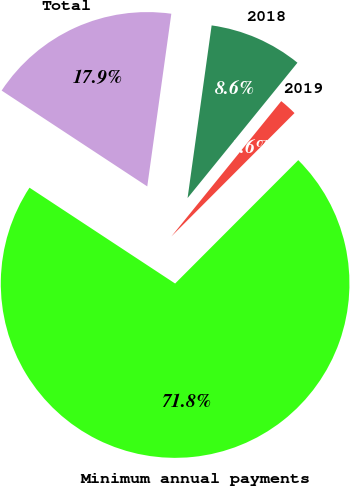<chart> <loc_0><loc_0><loc_500><loc_500><pie_chart><fcel>2018<fcel>2019<fcel>Minimum annual payments<fcel>Total<nl><fcel>8.65%<fcel>1.63%<fcel>71.78%<fcel>17.94%<nl></chart> 